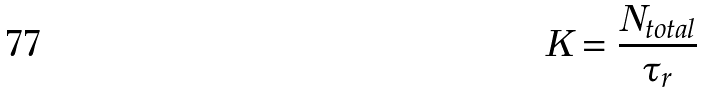<formula> <loc_0><loc_0><loc_500><loc_500>K = \frac { N _ { t o t a l } } { \tau _ { r } }</formula> 